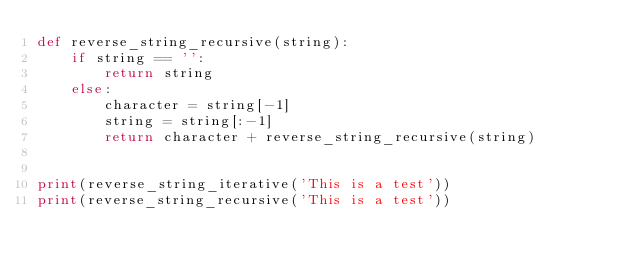<code> <loc_0><loc_0><loc_500><loc_500><_Python_>def reverse_string_recursive(string):
    if string == '':
        return string
    else:
        character = string[-1]
        string = string[:-1]
        return character + reverse_string_recursive(string)


print(reverse_string_iterative('This is a test'))
print(reverse_string_recursive('This is a test'))
</code> 